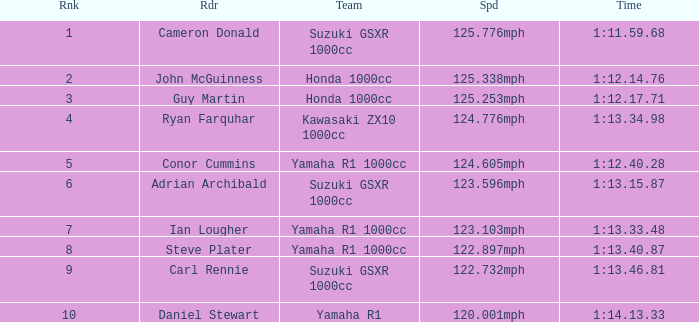What time did team kawasaki zx10 1000cc have? 1:13.34.98. 